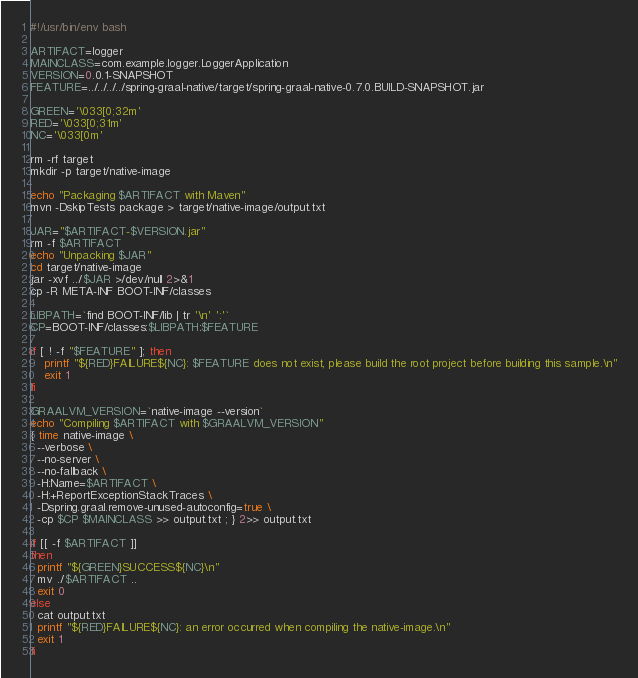<code> <loc_0><loc_0><loc_500><loc_500><_Bash_>#!/usr/bin/env bash

ARTIFACT=logger
MAINCLASS=com.example.logger.LoggerApplication
VERSION=0.0.1-SNAPSHOT
FEATURE=../../../../spring-graal-native/target/spring-graal-native-0.7.0.BUILD-SNAPSHOT.jar

GREEN='\033[0;32m'
RED='\033[0;31m'
NC='\033[0m'

rm -rf target
mkdir -p target/native-image

echo "Packaging $ARTIFACT with Maven"
mvn -DskipTests package > target/native-image/output.txt

JAR="$ARTIFACT-$VERSION.jar"
rm -f $ARTIFACT
echo "Unpacking $JAR"
cd target/native-image
jar -xvf ../$JAR >/dev/null 2>&1
cp -R META-INF BOOT-INF/classes

LIBPATH=`find BOOT-INF/lib | tr '\n' ':'`
CP=BOOT-INF/classes:$LIBPATH:$FEATURE

if [ ! -f "$FEATURE" ]; then
    printf "${RED}FAILURE${NC}: $FEATURE does not exist, please build the root project before building this sample.\n"
    exit 1
fi

GRAALVM_VERSION=`native-image --version`
echo "Compiling $ARTIFACT with $GRAALVM_VERSION"
{ time native-image \
  --verbose \
  --no-server \
  --no-fallback \
  -H:Name=$ARTIFACT \
  -H:+ReportExceptionStackTraces \
  -Dspring.graal.remove-unused-autoconfig=true \
  -cp $CP $MAINCLASS >> output.txt ; } 2>> output.txt

if [[ -f $ARTIFACT ]]
then
  printf "${GREEN}SUCCESS${NC}\n"
  mv ./$ARTIFACT ..
  exit 0
else
  cat output.txt
  printf "${RED}FAILURE${NC}: an error occurred when compiling the native-image.\n"
  exit 1
fi

</code> 